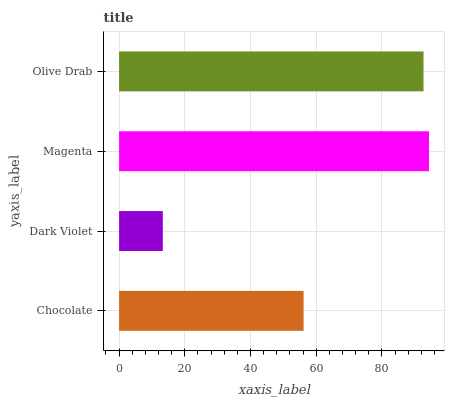Is Dark Violet the minimum?
Answer yes or no. Yes. Is Magenta the maximum?
Answer yes or no. Yes. Is Magenta the minimum?
Answer yes or no. No. Is Dark Violet the maximum?
Answer yes or no. No. Is Magenta greater than Dark Violet?
Answer yes or no. Yes. Is Dark Violet less than Magenta?
Answer yes or no. Yes. Is Dark Violet greater than Magenta?
Answer yes or no. No. Is Magenta less than Dark Violet?
Answer yes or no. No. Is Olive Drab the high median?
Answer yes or no. Yes. Is Chocolate the low median?
Answer yes or no. Yes. Is Chocolate the high median?
Answer yes or no. No. Is Olive Drab the low median?
Answer yes or no. No. 